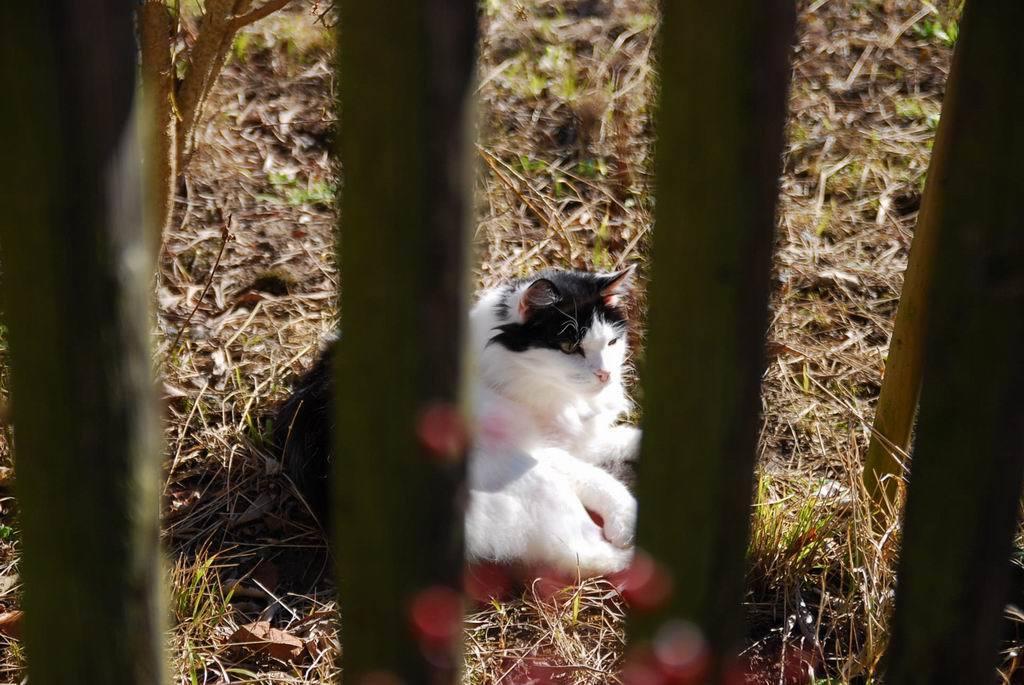Can you describe this image briefly? In this image we can see a cat on the ground and we can see the grass on the ground and there are some objects which looks like a wooden logs. 